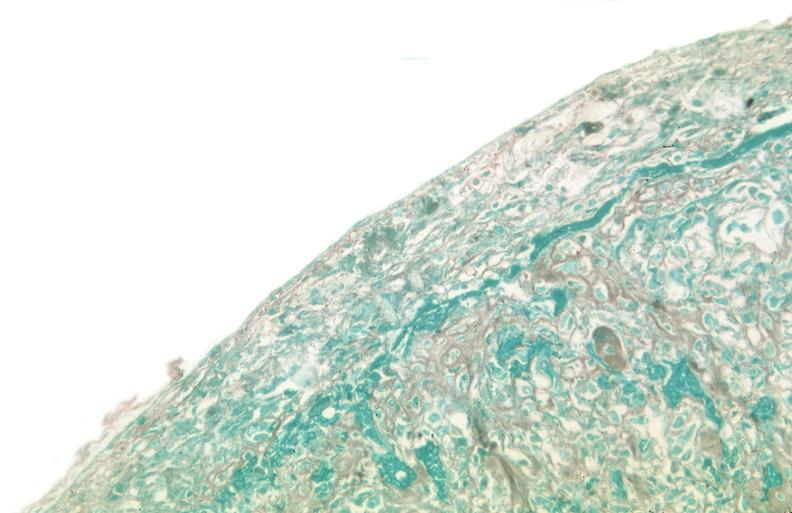was talc used to sclerose emphysematous lung, alpha-1 antitrypsin deficiency?
Answer the question using a single word or phrase. Yes 